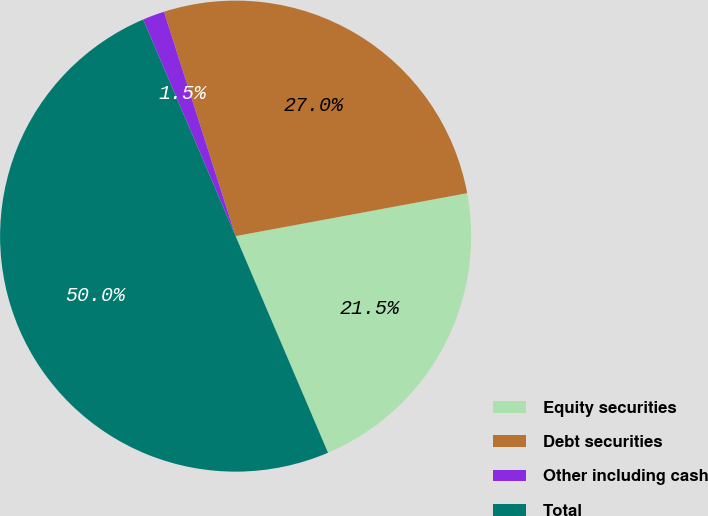<chart> <loc_0><loc_0><loc_500><loc_500><pie_chart><fcel>Equity securities<fcel>Debt securities<fcel>Other including cash<fcel>Total<nl><fcel>21.5%<fcel>27.0%<fcel>1.5%<fcel>50.0%<nl></chart> 